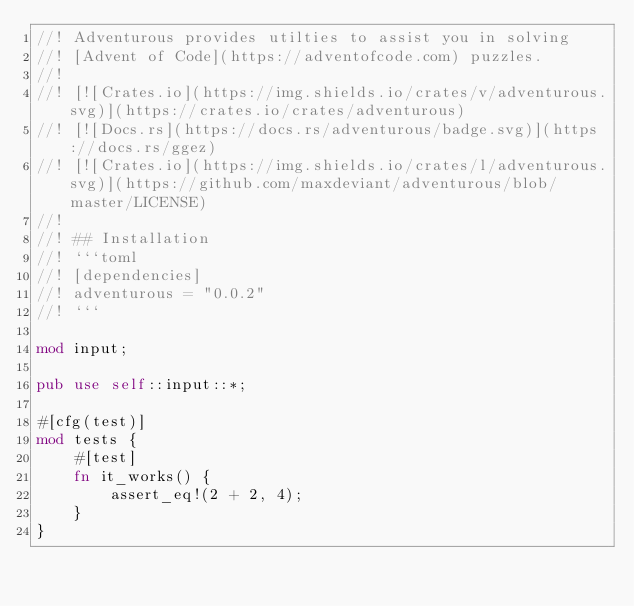<code> <loc_0><loc_0><loc_500><loc_500><_Rust_>//! Adventurous provides utilties to assist you in solving
//! [Advent of Code](https://adventofcode.com) puzzles.
//!
//! [![Crates.io](https://img.shields.io/crates/v/adventurous.svg)](https://crates.io/crates/adventurous)
//! [![Docs.rs](https://docs.rs/adventurous/badge.svg)](https://docs.rs/ggez)
//! [![Crates.io](https://img.shields.io/crates/l/adventurous.svg)](https://github.com/maxdeviant/adventurous/blob/master/LICENSE)
//!
//! ## Installation
//! ```toml
//! [dependencies]
//! adventurous = "0.0.2"
//! ```

mod input;

pub use self::input::*;

#[cfg(test)]
mod tests {
    #[test]
    fn it_works() {
        assert_eq!(2 + 2, 4);
    }
}
</code> 